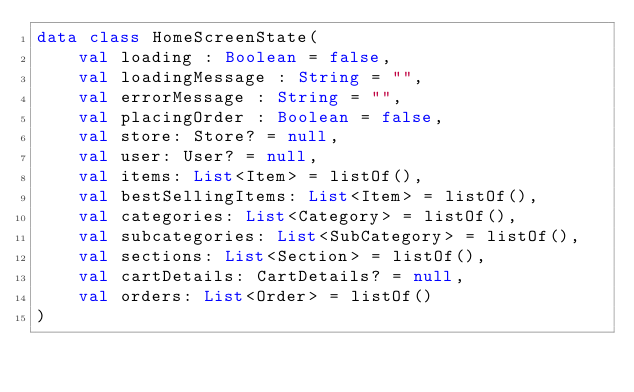Convert code to text. <code><loc_0><loc_0><loc_500><loc_500><_Kotlin_>data class HomeScreenState(
    val loading : Boolean = false,
    val loadingMessage : String = "",
    val errorMessage : String = "",
    val placingOrder : Boolean = false,
    val store: Store? = null,
    val user: User? = null,
    val items: List<Item> = listOf(),
    val bestSellingItems: List<Item> = listOf(),
    val categories: List<Category> = listOf(),
    val subcategories: List<SubCategory> = listOf(),
    val sections: List<Section> = listOf(),
    val cartDetails: CartDetails? = null,
    val orders: List<Order> = listOf()
)</code> 